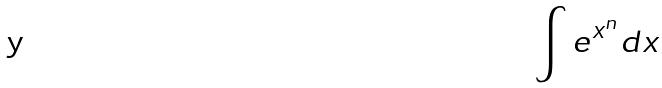Convert formula to latex. <formula><loc_0><loc_0><loc_500><loc_500>\int e ^ { x ^ { n } } d x</formula> 